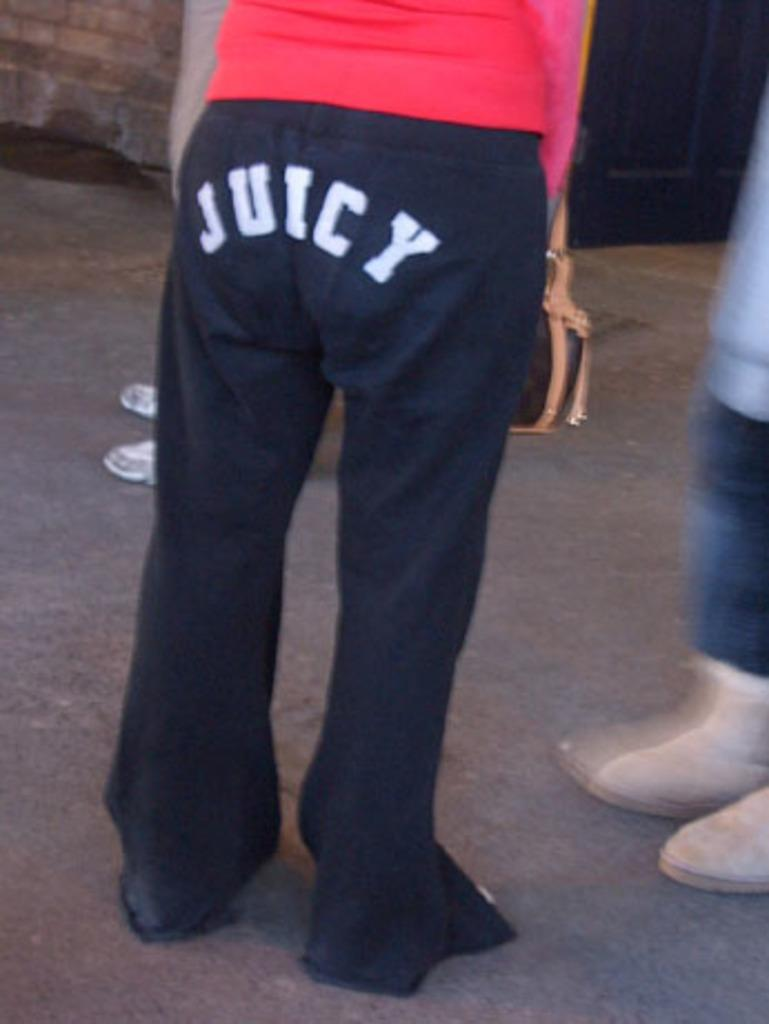<image>
Share a concise interpretation of the image provided. Several people are standing around, the main focus of this image is of a woman in a red shirt and black sweats with the word "JUICY" written on the backside. 